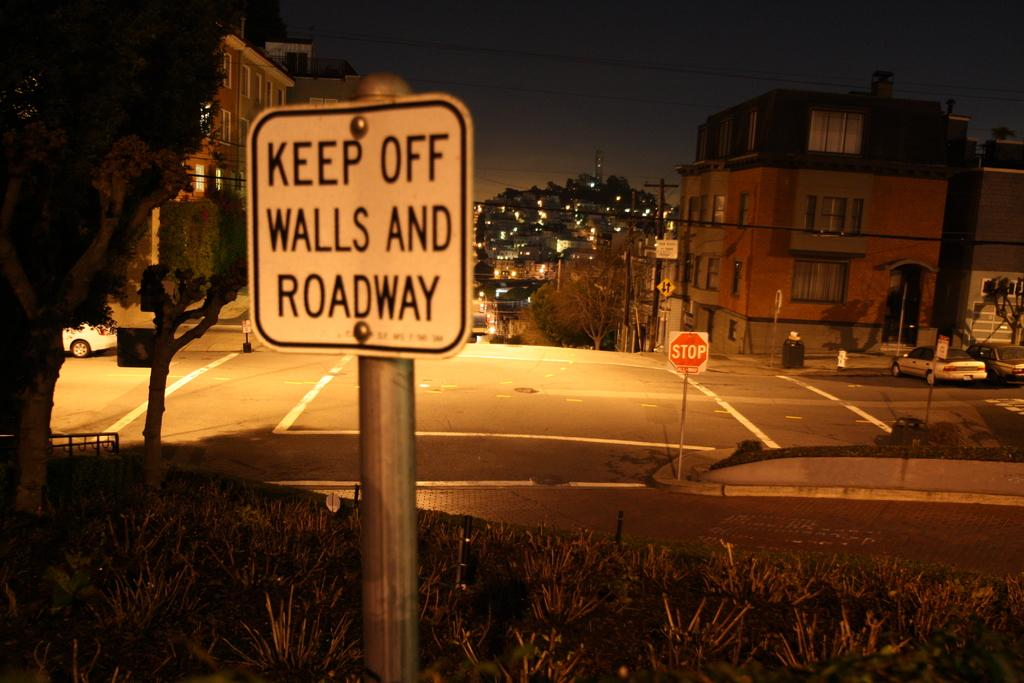Provide a one-sentence caption for the provided image. A sign outside in the grass at night stating keep off the walls and roadway. 